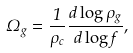Convert formula to latex. <formula><loc_0><loc_0><loc_500><loc_500>\Omega _ { g } = \frac { 1 } { \rho _ { c } } \frac { d \log \rho _ { g } } { d \log f } ,</formula> 